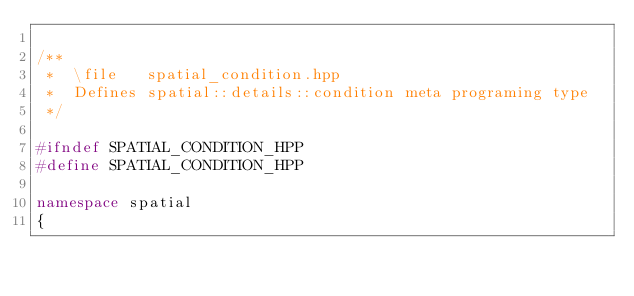Convert code to text. <code><loc_0><loc_0><loc_500><loc_500><_C++_>
/**
 *  \file   spatial_condition.hpp
 *  Defines spatial::details::condition meta programing type
 */

#ifndef SPATIAL_CONDITION_HPP
#define SPATIAL_CONDITION_HPP

namespace spatial
{</code> 